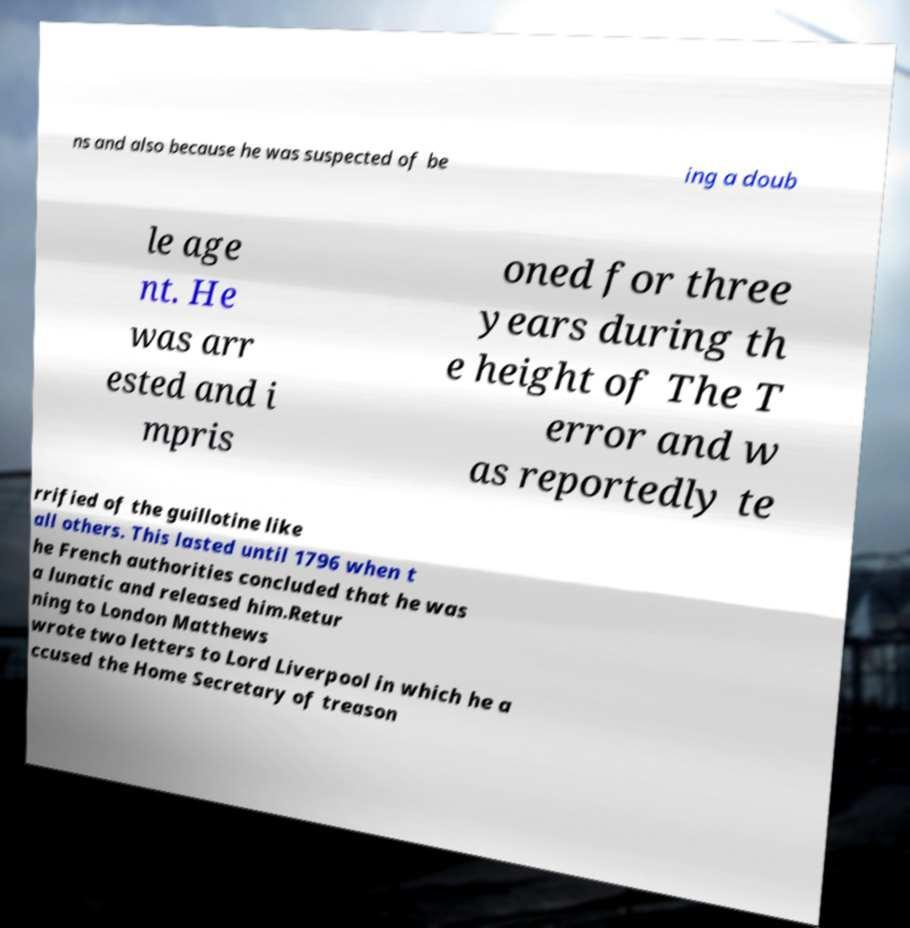Could you extract and type out the text from this image? ns and also because he was suspected of be ing a doub le age nt. He was arr ested and i mpris oned for three years during th e height of The T error and w as reportedly te rrified of the guillotine like all others. This lasted until 1796 when t he French authorities concluded that he was a lunatic and released him.Retur ning to London Matthews wrote two letters to Lord Liverpool in which he a ccused the Home Secretary of treason 